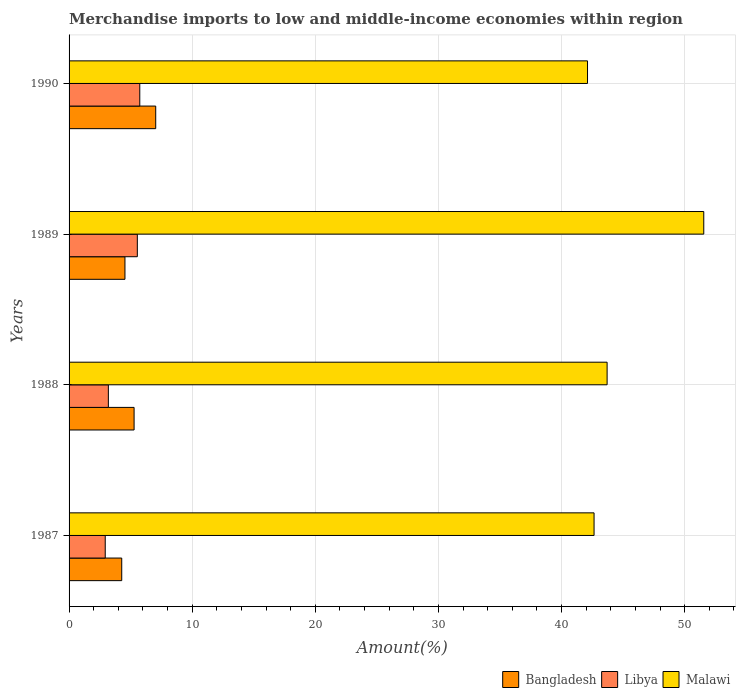How many groups of bars are there?
Provide a short and direct response. 4. How many bars are there on the 2nd tick from the bottom?
Keep it short and to the point. 3. What is the percentage of amount earned from merchandise imports in Libya in 1990?
Offer a very short reply. 5.74. Across all years, what is the maximum percentage of amount earned from merchandise imports in Libya?
Ensure brevity in your answer.  5.74. Across all years, what is the minimum percentage of amount earned from merchandise imports in Bangladesh?
Your answer should be compact. 4.28. In which year was the percentage of amount earned from merchandise imports in Bangladesh maximum?
Keep it short and to the point. 1990. In which year was the percentage of amount earned from merchandise imports in Bangladesh minimum?
Your response must be concise. 1987. What is the total percentage of amount earned from merchandise imports in Malawi in the graph?
Your response must be concise. 180.02. What is the difference between the percentage of amount earned from merchandise imports in Libya in 1987 and that in 1990?
Your response must be concise. -2.81. What is the difference between the percentage of amount earned from merchandise imports in Malawi in 1990 and the percentage of amount earned from merchandise imports in Libya in 1989?
Your answer should be very brief. 36.57. What is the average percentage of amount earned from merchandise imports in Libya per year?
Ensure brevity in your answer.  4.35. In the year 1987, what is the difference between the percentage of amount earned from merchandise imports in Malawi and percentage of amount earned from merchandise imports in Libya?
Make the answer very short. 39.71. In how many years, is the percentage of amount earned from merchandise imports in Bangladesh greater than 4 %?
Offer a terse response. 4. What is the ratio of the percentage of amount earned from merchandise imports in Libya in 1989 to that in 1990?
Your answer should be compact. 0.97. What is the difference between the highest and the second highest percentage of amount earned from merchandise imports in Malawi?
Keep it short and to the point. 7.85. What is the difference between the highest and the lowest percentage of amount earned from merchandise imports in Bangladesh?
Give a very brief answer. 2.76. What does the 2nd bar from the top in 1990 represents?
Offer a terse response. Libya. What does the 3rd bar from the bottom in 1988 represents?
Provide a succinct answer. Malawi. Is it the case that in every year, the sum of the percentage of amount earned from merchandise imports in Malawi and percentage of amount earned from merchandise imports in Bangladesh is greater than the percentage of amount earned from merchandise imports in Libya?
Offer a very short reply. Yes. How many bars are there?
Offer a very short reply. 12. Are all the bars in the graph horizontal?
Your answer should be compact. Yes. How many years are there in the graph?
Offer a terse response. 4. What is the difference between two consecutive major ticks on the X-axis?
Offer a very short reply. 10. Are the values on the major ticks of X-axis written in scientific E-notation?
Offer a terse response. No. Does the graph contain any zero values?
Keep it short and to the point. No. Where does the legend appear in the graph?
Your answer should be compact. Bottom right. How many legend labels are there?
Offer a very short reply. 3. How are the legend labels stacked?
Offer a terse response. Horizontal. What is the title of the graph?
Offer a very short reply. Merchandise imports to low and middle-income economies within region. Does "Cyprus" appear as one of the legend labels in the graph?
Your response must be concise. No. What is the label or title of the X-axis?
Provide a succinct answer. Amount(%). What is the label or title of the Y-axis?
Provide a short and direct response. Years. What is the Amount(%) in Bangladesh in 1987?
Your answer should be very brief. 4.28. What is the Amount(%) in Libya in 1987?
Offer a very short reply. 2.94. What is the Amount(%) in Malawi in 1987?
Offer a terse response. 42.64. What is the Amount(%) of Bangladesh in 1988?
Ensure brevity in your answer.  5.28. What is the Amount(%) in Libya in 1988?
Offer a very short reply. 3.19. What is the Amount(%) of Malawi in 1988?
Your response must be concise. 43.7. What is the Amount(%) in Bangladesh in 1989?
Give a very brief answer. 4.54. What is the Amount(%) in Libya in 1989?
Keep it short and to the point. 5.54. What is the Amount(%) in Malawi in 1989?
Offer a terse response. 51.55. What is the Amount(%) of Bangladesh in 1990?
Offer a terse response. 7.04. What is the Amount(%) in Libya in 1990?
Provide a short and direct response. 5.74. What is the Amount(%) in Malawi in 1990?
Offer a terse response. 42.11. Across all years, what is the maximum Amount(%) of Bangladesh?
Your answer should be very brief. 7.04. Across all years, what is the maximum Amount(%) of Libya?
Offer a very short reply. 5.74. Across all years, what is the maximum Amount(%) in Malawi?
Provide a short and direct response. 51.55. Across all years, what is the minimum Amount(%) in Bangladesh?
Make the answer very short. 4.28. Across all years, what is the minimum Amount(%) of Libya?
Offer a terse response. 2.94. Across all years, what is the minimum Amount(%) of Malawi?
Make the answer very short. 42.11. What is the total Amount(%) of Bangladesh in the graph?
Make the answer very short. 21.14. What is the total Amount(%) of Libya in the graph?
Your answer should be compact. 17.42. What is the total Amount(%) of Malawi in the graph?
Provide a succinct answer. 180.02. What is the difference between the Amount(%) of Bangladesh in 1987 and that in 1988?
Give a very brief answer. -1. What is the difference between the Amount(%) of Libya in 1987 and that in 1988?
Your answer should be compact. -0.25. What is the difference between the Amount(%) of Malawi in 1987 and that in 1988?
Provide a short and direct response. -1.06. What is the difference between the Amount(%) of Bangladesh in 1987 and that in 1989?
Your answer should be very brief. -0.26. What is the difference between the Amount(%) of Libya in 1987 and that in 1989?
Your response must be concise. -2.61. What is the difference between the Amount(%) of Malawi in 1987 and that in 1989?
Provide a short and direct response. -8.91. What is the difference between the Amount(%) in Bangladesh in 1987 and that in 1990?
Your answer should be very brief. -2.76. What is the difference between the Amount(%) of Libya in 1987 and that in 1990?
Your response must be concise. -2.81. What is the difference between the Amount(%) in Malawi in 1987 and that in 1990?
Your answer should be very brief. 0.53. What is the difference between the Amount(%) of Bangladesh in 1988 and that in 1989?
Offer a very short reply. 0.74. What is the difference between the Amount(%) of Libya in 1988 and that in 1989?
Give a very brief answer. -2.35. What is the difference between the Amount(%) of Malawi in 1988 and that in 1989?
Keep it short and to the point. -7.85. What is the difference between the Amount(%) of Bangladesh in 1988 and that in 1990?
Make the answer very short. -1.76. What is the difference between the Amount(%) of Libya in 1988 and that in 1990?
Provide a short and direct response. -2.55. What is the difference between the Amount(%) in Malawi in 1988 and that in 1990?
Your response must be concise. 1.59. What is the difference between the Amount(%) in Bangladesh in 1989 and that in 1990?
Your response must be concise. -2.5. What is the difference between the Amount(%) in Libya in 1989 and that in 1990?
Give a very brief answer. -0.2. What is the difference between the Amount(%) in Malawi in 1989 and that in 1990?
Make the answer very short. 9.44. What is the difference between the Amount(%) of Bangladesh in 1987 and the Amount(%) of Libya in 1988?
Provide a short and direct response. 1.09. What is the difference between the Amount(%) of Bangladesh in 1987 and the Amount(%) of Malawi in 1988?
Provide a succinct answer. -39.43. What is the difference between the Amount(%) of Libya in 1987 and the Amount(%) of Malawi in 1988?
Ensure brevity in your answer.  -40.77. What is the difference between the Amount(%) in Bangladesh in 1987 and the Amount(%) in Libya in 1989?
Your response must be concise. -1.27. What is the difference between the Amount(%) in Bangladesh in 1987 and the Amount(%) in Malawi in 1989?
Offer a very short reply. -47.28. What is the difference between the Amount(%) of Libya in 1987 and the Amount(%) of Malawi in 1989?
Your answer should be compact. -48.62. What is the difference between the Amount(%) in Bangladesh in 1987 and the Amount(%) in Libya in 1990?
Keep it short and to the point. -1.47. What is the difference between the Amount(%) of Bangladesh in 1987 and the Amount(%) of Malawi in 1990?
Ensure brevity in your answer.  -37.83. What is the difference between the Amount(%) of Libya in 1987 and the Amount(%) of Malawi in 1990?
Provide a succinct answer. -39.17. What is the difference between the Amount(%) of Bangladesh in 1988 and the Amount(%) of Libya in 1989?
Give a very brief answer. -0.26. What is the difference between the Amount(%) of Bangladesh in 1988 and the Amount(%) of Malawi in 1989?
Your answer should be compact. -46.27. What is the difference between the Amount(%) in Libya in 1988 and the Amount(%) in Malawi in 1989?
Offer a very short reply. -48.36. What is the difference between the Amount(%) of Bangladesh in 1988 and the Amount(%) of Libya in 1990?
Ensure brevity in your answer.  -0.46. What is the difference between the Amount(%) of Bangladesh in 1988 and the Amount(%) of Malawi in 1990?
Provide a short and direct response. -36.83. What is the difference between the Amount(%) in Libya in 1988 and the Amount(%) in Malawi in 1990?
Your answer should be compact. -38.92. What is the difference between the Amount(%) in Bangladesh in 1989 and the Amount(%) in Libya in 1990?
Your response must be concise. -1.21. What is the difference between the Amount(%) of Bangladesh in 1989 and the Amount(%) of Malawi in 1990?
Offer a terse response. -37.57. What is the difference between the Amount(%) of Libya in 1989 and the Amount(%) of Malawi in 1990?
Make the answer very short. -36.57. What is the average Amount(%) in Bangladesh per year?
Make the answer very short. 5.28. What is the average Amount(%) in Libya per year?
Your answer should be compact. 4.35. What is the average Amount(%) of Malawi per year?
Offer a very short reply. 45. In the year 1987, what is the difference between the Amount(%) of Bangladesh and Amount(%) of Libya?
Ensure brevity in your answer.  1.34. In the year 1987, what is the difference between the Amount(%) in Bangladesh and Amount(%) in Malawi?
Offer a terse response. -38.37. In the year 1987, what is the difference between the Amount(%) of Libya and Amount(%) of Malawi?
Your answer should be compact. -39.71. In the year 1988, what is the difference between the Amount(%) in Bangladesh and Amount(%) in Libya?
Your answer should be compact. 2.09. In the year 1988, what is the difference between the Amount(%) in Bangladesh and Amount(%) in Malawi?
Your response must be concise. -38.42. In the year 1988, what is the difference between the Amount(%) of Libya and Amount(%) of Malawi?
Ensure brevity in your answer.  -40.51. In the year 1989, what is the difference between the Amount(%) in Bangladesh and Amount(%) in Libya?
Make the answer very short. -1. In the year 1989, what is the difference between the Amount(%) of Bangladesh and Amount(%) of Malawi?
Offer a very short reply. -47.02. In the year 1989, what is the difference between the Amount(%) in Libya and Amount(%) in Malawi?
Make the answer very short. -46.01. In the year 1990, what is the difference between the Amount(%) of Bangladesh and Amount(%) of Libya?
Provide a short and direct response. 1.29. In the year 1990, what is the difference between the Amount(%) of Bangladesh and Amount(%) of Malawi?
Your answer should be compact. -35.07. In the year 1990, what is the difference between the Amount(%) in Libya and Amount(%) in Malawi?
Give a very brief answer. -36.37. What is the ratio of the Amount(%) in Bangladesh in 1987 to that in 1988?
Your answer should be very brief. 0.81. What is the ratio of the Amount(%) of Libya in 1987 to that in 1988?
Provide a succinct answer. 0.92. What is the ratio of the Amount(%) in Malawi in 1987 to that in 1988?
Make the answer very short. 0.98. What is the ratio of the Amount(%) of Bangladesh in 1987 to that in 1989?
Provide a short and direct response. 0.94. What is the ratio of the Amount(%) in Libya in 1987 to that in 1989?
Your response must be concise. 0.53. What is the ratio of the Amount(%) of Malawi in 1987 to that in 1989?
Give a very brief answer. 0.83. What is the ratio of the Amount(%) in Bangladesh in 1987 to that in 1990?
Offer a very short reply. 0.61. What is the ratio of the Amount(%) of Libya in 1987 to that in 1990?
Make the answer very short. 0.51. What is the ratio of the Amount(%) in Malawi in 1987 to that in 1990?
Ensure brevity in your answer.  1.01. What is the ratio of the Amount(%) of Bangladesh in 1988 to that in 1989?
Give a very brief answer. 1.16. What is the ratio of the Amount(%) in Libya in 1988 to that in 1989?
Your answer should be very brief. 0.58. What is the ratio of the Amount(%) of Malawi in 1988 to that in 1989?
Make the answer very short. 0.85. What is the ratio of the Amount(%) in Bangladesh in 1988 to that in 1990?
Provide a succinct answer. 0.75. What is the ratio of the Amount(%) in Libya in 1988 to that in 1990?
Your answer should be very brief. 0.56. What is the ratio of the Amount(%) of Malawi in 1988 to that in 1990?
Your answer should be compact. 1.04. What is the ratio of the Amount(%) of Bangladesh in 1989 to that in 1990?
Offer a terse response. 0.64. What is the ratio of the Amount(%) in Libya in 1989 to that in 1990?
Make the answer very short. 0.97. What is the ratio of the Amount(%) in Malawi in 1989 to that in 1990?
Give a very brief answer. 1.22. What is the difference between the highest and the second highest Amount(%) of Bangladesh?
Your answer should be compact. 1.76. What is the difference between the highest and the second highest Amount(%) of Libya?
Provide a short and direct response. 0.2. What is the difference between the highest and the second highest Amount(%) of Malawi?
Give a very brief answer. 7.85. What is the difference between the highest and the lowest Amount(%) of Bangladesh?
Your answer should be compact. 2.76. What is the difference between the highest and the lowest Amount(%) of Libya?
Keep it short and to the point. 2.81. What is the difference between the highest and the lowest Amount(%) in Malawi?
Offer a very short reply. 9.44. 